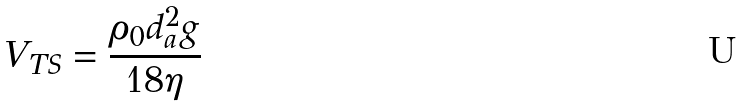Convert formula to latex. <formula><loc_0><loc_0><loc_500><loc_500>V _ { T S } = \frac { \rho _ { 0 } d _ { a } ^ { 2 } g } { 1 8 \eta }</formula> 